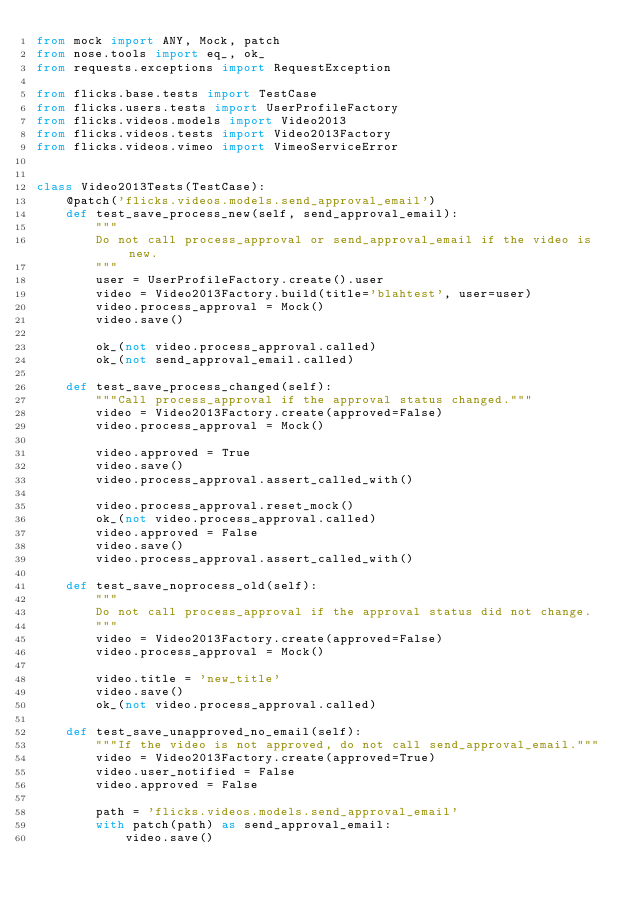Convert code to text. <code><loc_0><loc_0><loc_500><loc_500><_Python_>from mock import ANY, Mock, patch
from nose.tools import eq_, ok_
from requests.exceptions import RequestException

from flicks.base.tests import TestCase
from flicks.users.tests import UserProfileFactory
from flicks.videos.models import Video2013
from flicks.videos.tests import Video2013Factory
from flicks.videos.vimeo import VimeoServiceError


class Video2013Tests(TestCase):
    @patch('flicks.videos.models.send_approval_email')
    def test_save_process_new(self, send_approval_email):
        """
        Do not call process_approval or send_approval_email if the video is new.
        """
        user = UserProfileFactory.create().user
        video = Video2013Factory.build(title='blahtest', user=user)
        video.process_approval = Mock()
        video.save()

        ok_(not video.process_approval.called)
        ok_(not send_approval_email.called)

    def test_save_process_changed(self):
        """Call process_approval if the approval status changed."""
        video = Video2013Factory.create(approved=False)
        video.process_approval = Mock()

        video.approved = True
        video.save()
        video.process_approval.assert_called_with()

        video.process_approval.reset_mock()
        ok_(not video.process_approval.called)
        video.approved = False
        video.save()
        video.process_approval.assert_called_with()

    def test_save_noprocess_old(self):
        """
        Do not call process_approval if the approval status did not change.
        """
        video = Video2013Factory.create(approved=False)
        video.process_approval = Mock()

        video.title = 'new_title'
        video.save()
        ok_(not video.process_approval.called)

    def test_save_unapproved_no_email(self):
        """If the video is not approved, do not call send_approval_email."""
        video = Video2013Factory.create(approved=True)
        video.user_notified = False
        video.approved = False

        path = 'flicks.videos.models.send_approval_email'
        with patch(path) as send_approval_email:
            video.save()</code> 